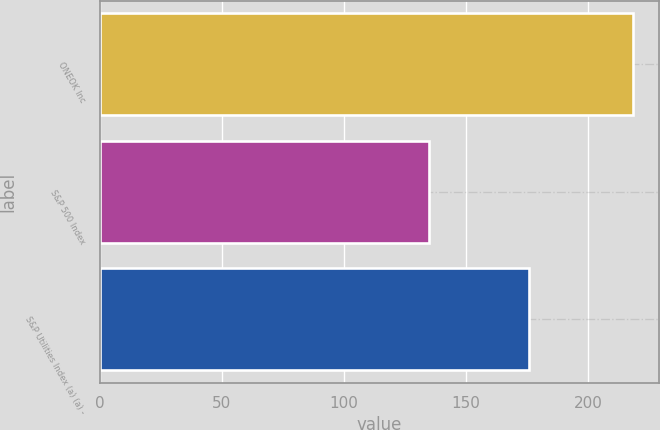<chart> <loc_0><loc_0><loc_500><loc_500><bar_chart><fcel>ONEOK Inc<fcel>S&P 500 Index<fcel>S&P Utilities Index (a) (a) -<nl><fcel>218.1<fcel>134.69<fcel>175.69<nl></chart> 